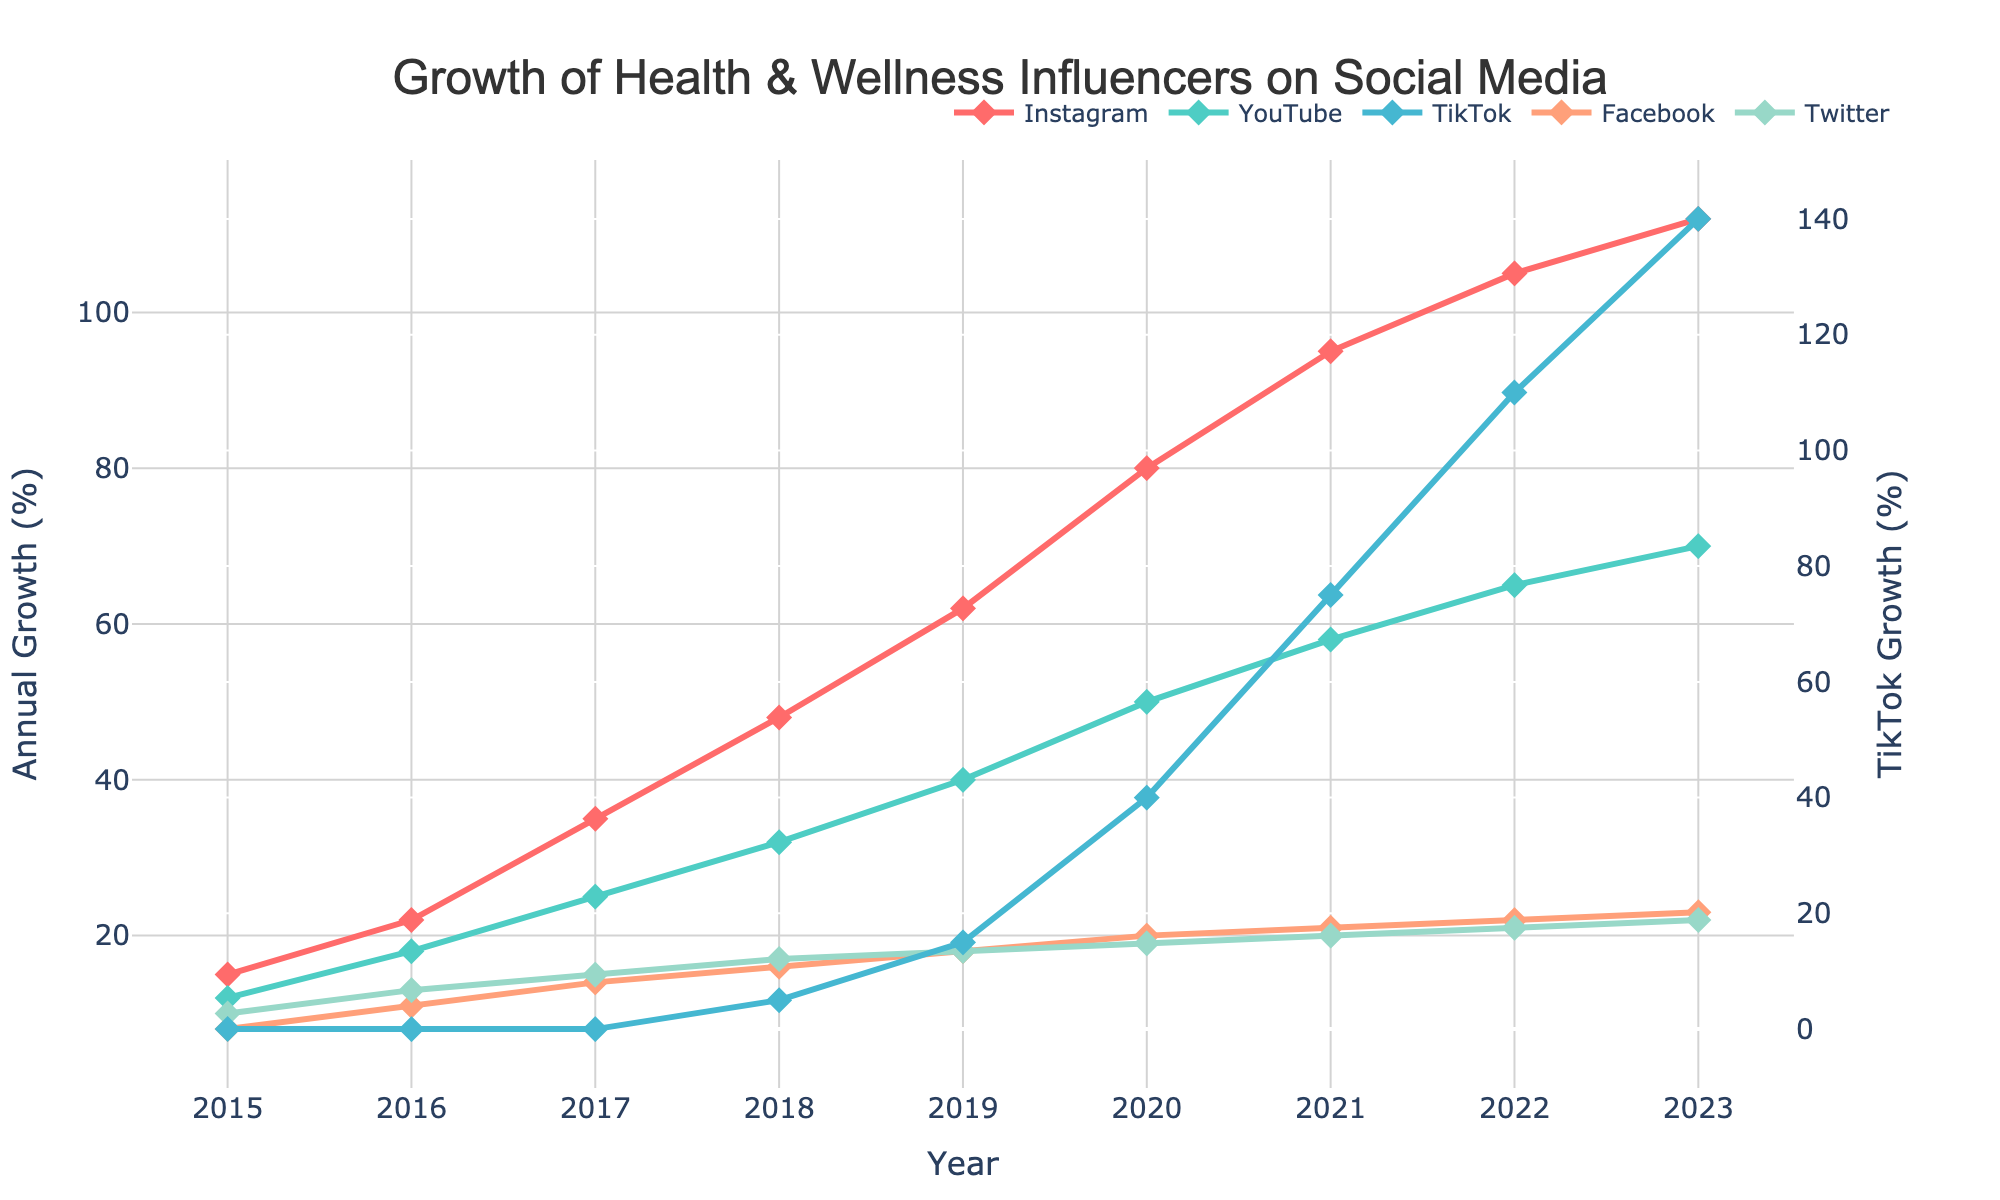What year did TikTok start showing follower growth for health and wellness influencers? TikTok follower growth starts showing in 2018, as indicated by the first non-zero value in the TikTok line.
Answer: 2018 Which platform had the highest follower growth in 2023? In 2023, the platform with the highest follower growth is TikTok, reaching 140.
Answer: TikTok Between Instagram and YouTube, which platform had a larger increase in follower growth from 2017 to 2018? Instagram increased from 35 to 48, which is a difference of 13; YouTube increased from 25 to 32, which is a difference of 7. Therefore, Instagram had a larger increase.
Answer: Instagram Calculate the average annual growth for Facebook from 2015 to 2023. Sum of Facebook growth from 2015 to 2023 is 8 + 11 + 14 + 16 + 18 + 20 + 21 + 22 + 23 = 153. There are 9 years, so the average is 153/9 = 17.
Answer: 17 Which platform saw the highest growth rate difference between two consecutive years? TikTok shows the highest growth rate difference between 2020 and 2021, with a growth from 40 to 75, a difference of 35.
Answer: TikTok In 2021, which platform's growth exceeded that of Twitter the most? In 2021, TikTok's growth was 75, Twitter's was 20, and the difference is 75 - 20 = 55.
Answer: TikTok Comparing Instagram and Twitter, by how much did Instagram's growth exceed Twitter's in 2020? In 2020, Instagram's growth was 80 and Twitter's was 19, the difference being 80 - 19 = 61.
Answer: 61 Is there any year where Facebook's growth plateaued and did not increase? Facebook's growth increased every year, as seen from the gradual rise from 8 in 2015 to 23 in 2023. There is no plateau year.
Answer: No Which year did Twitter reach a growth above 20? Twitter reached a growth above 20 in 2022, showing 21.
Answer: 2022 What is the combined follower growth for YouTube and Facebook in 2016? YouTube's growth was 18 and Facebook's was 11 in 2016, adding up to 18 + 11 = 29.
Answer: 29 